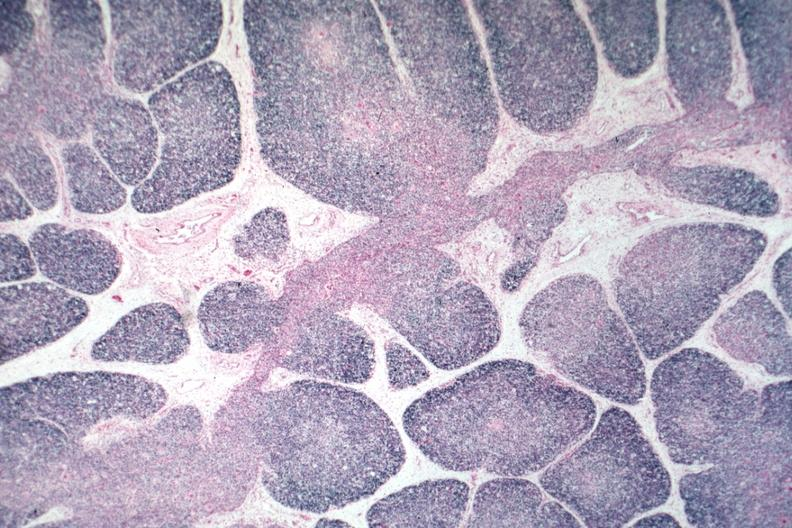s this good yellow color slide present?
Answer the question using a single word or phrase. No 